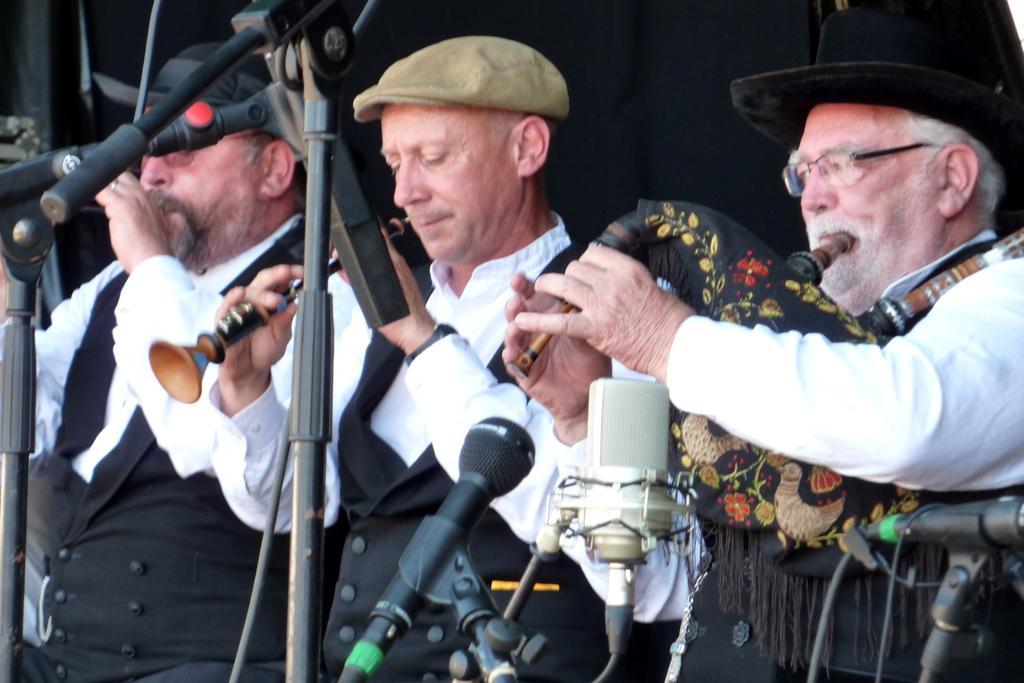How would you summarize this image in a sentence or two? In the foreground of this image, there are three men standing in black and white dresses holding musical instrument in the hands in front of mics. Among them one is playing bagpipes and another is playing clarinet. 